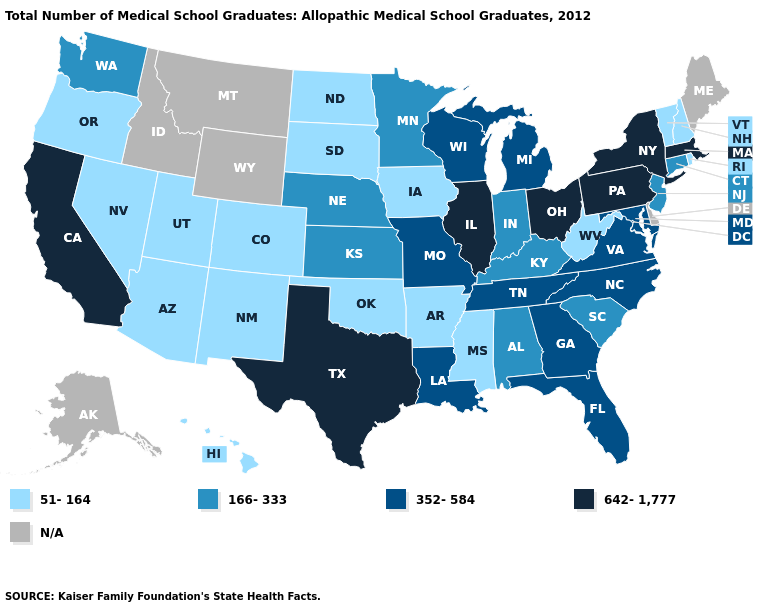Which states have the lowest value in the South?
Quick response, please. Arkansas, Mississippi, Oklahoma, West Virginia. What is the highest value in states that border Maine?
Keep it brief. 51-164. Name the states that have a value in the range N/A?
Short answer required. Alaska, Delaware, Idaho, Maine, Montana, Wyoming. Among the states that border Georgia , which have the lowest value?
Keep it brief. Alabama, South Carolina. Name the states that have a value in the range 352-584?
Quick response, please. Florida, Georgia, Louisiana, Maryland, Michigan, Missouri, North Carolina, Tennessee, Virginia, Wisconsin. Does the first symbol in the legend represent the smallest category?
Quick response, please. Yes. How many symbols are there in the legend?
Short answer required. 5. Name the states that have a value in the range 352-584?
Be succinct. Florida, Georgia, Louisiana, Maryland, Michigan, Missouri, North Carolina, Tennessee, Virginia, Wisconsin. Name the states that have a value in the range 642-1,777?
Be succinct. California, Illinois, Massachusetts, New York, Ohio, Pennsylvania, Texas. What is the value of North Carolina?
Give a very brief answer. 352-584. What is the value of Tennessee?
Write a very short answer. 352-584. Name the states that have a value in the range 166-333?
Short answer required. Alabama, Connecticut, Indiana, Kansas, Kentucky, Minnesota, Nebraska, New Jersey, South Carolina, Washington. What is the value of Hawaii?
Concise answer only. 51-164. Among the states that border Colorado , does Nebraska have the highest value?
Concise answer only. Yes. 